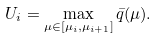<formula> <loc_0><loc_0><loc_500><loc_500>U _ { i } = \max _ { \mu \in [ \mu _ { i } , \mu _ { i + 1 } ] } \bar { q } ( \mu ) .</formula> 